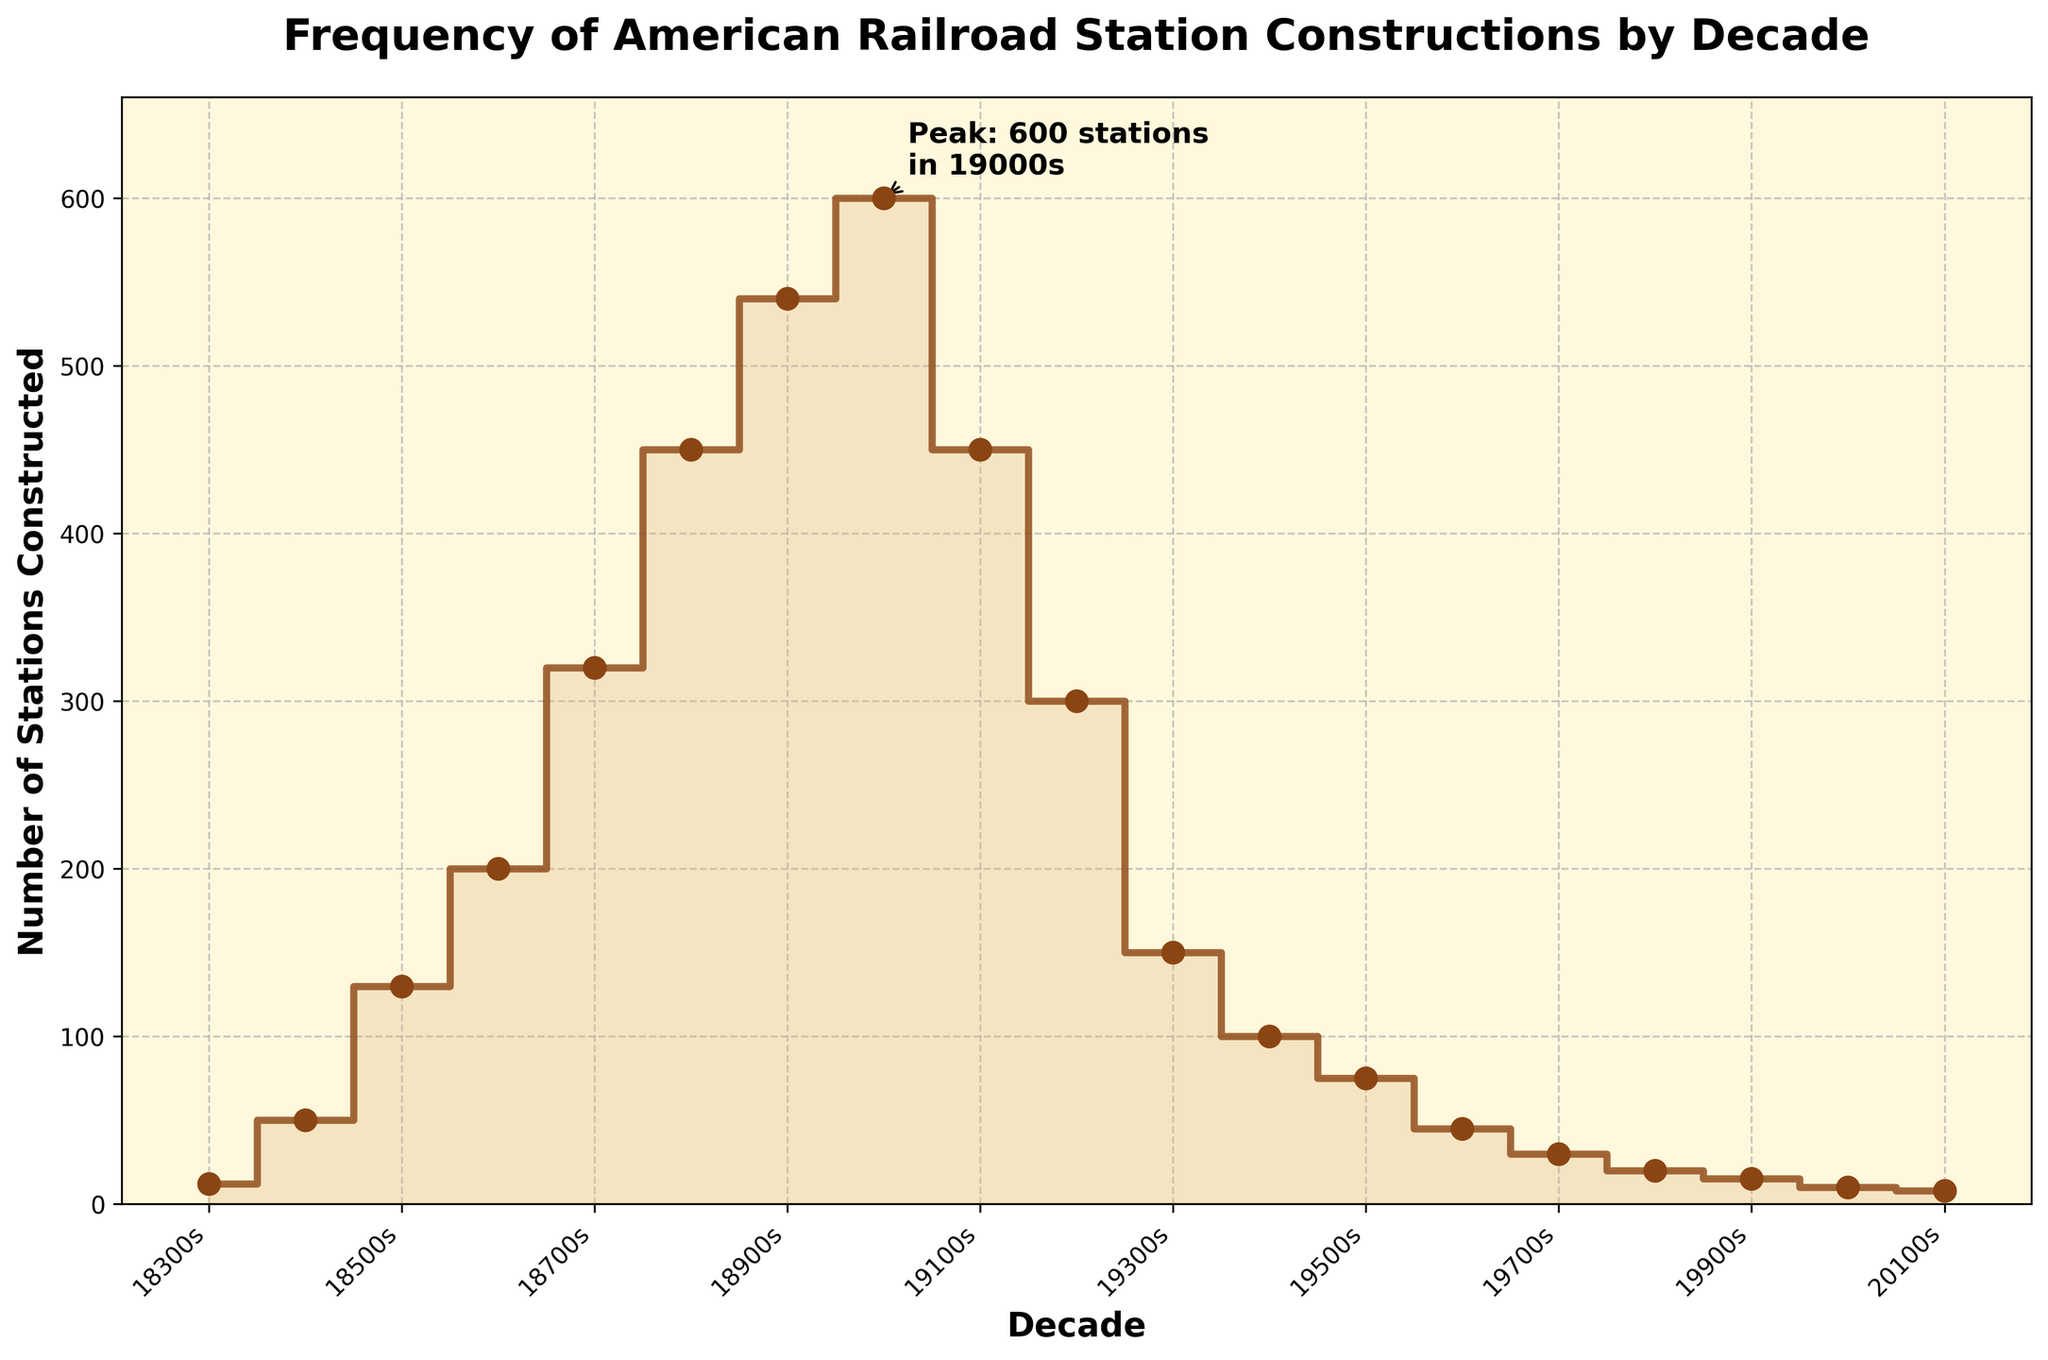what is the title of the figure? The title is located at the top of the plot and it provides a summary of what the data represents. The title reads "Frequency of American Railroad Station Constructions by Decade".
Answer: Frequency of American Railroad Station Constructions by Decade Which decade had the peak number of station constructions? The peak number of station constructions occurred in the 1900s as annotated on the plot with "Peak: 600 stations in 1900s".
Answer: 1900s Compare the number of stations constructed in the 1880s to the 1920s. Which decade had a higher construction number? By examining the y-axis values of the stair plot, the 1880s had approximately 450 stations constructed, whereas the 1920s had about 300 stations constructed. Thus, the 1880s had a higher construction number.
Answer: 1880s How many stations were constructed in the 1950s? Look at the value on the y-axis corresponding to the 1950s on the x-axis. The stair steps show that about 75 stations were constructed in this decade.
Answer: 75 Between which two consecutive decades did the largest decrease in construction occur? Observe the vertical drops between consecutive steps. The largest decrease occurs from the 1900s (600 stations) to the 1910s (450 stations), a drop of 150 stations.
Answer: From 1900s to 1910s What is the approximate total number of stations constructed from the 1830s to the 2010s? Add up the y-axis values of the stair steps for each decade: 12 + 50 + 130 + 200 + 320 + 450 + 540 + 600 + 450 + 300 + 150 + 100 + 75 + 45 + 30 + 20 + 15 + 10 + 8 = 3405
Answer: 3405 Which decade had the same number of stations constructed as the 1930s? By examining the heights of the steps, both the 1930s and the 1940s had around 150 stations constructed.
Answer: 1940s What was the trend in the number of stations constructed after the peak in the 1900s? After the peak in the 1900s, the number of stations constructed generally declined, as seen by the downward steps in the plot.
Answer: Decline What is the difference in the number of stations built between the 1860s and 1960s? The 1860s had about 200 stations constructed and the 1960s had about 45 stations. The difference is 200 - 45 = 155.
Answer: 155 